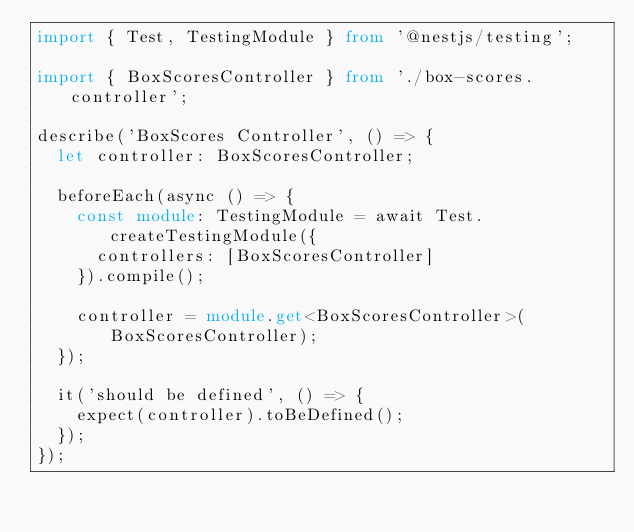<code> <loc_0><loc_0><loc_500><loc_500><_TypeScript_>import { Test, TestingModule } from '@nestjs/testing';

import { BoxScoresController } from './box-scores.controller';

describe('BoxScores Controller', () => {
  let controller: BoxScoresController;

  beforeEach(async () => {
    const module: TestingModule = await Test.createTestingModule({
      controllers: [BoxScoresController]
    }).compile();

    controller = module.get<BoxScoresController>(BoxScoresController);
  });

  it('should be defined', () => {
    expect(controller).toBeDefined();
  });
});
</code> 